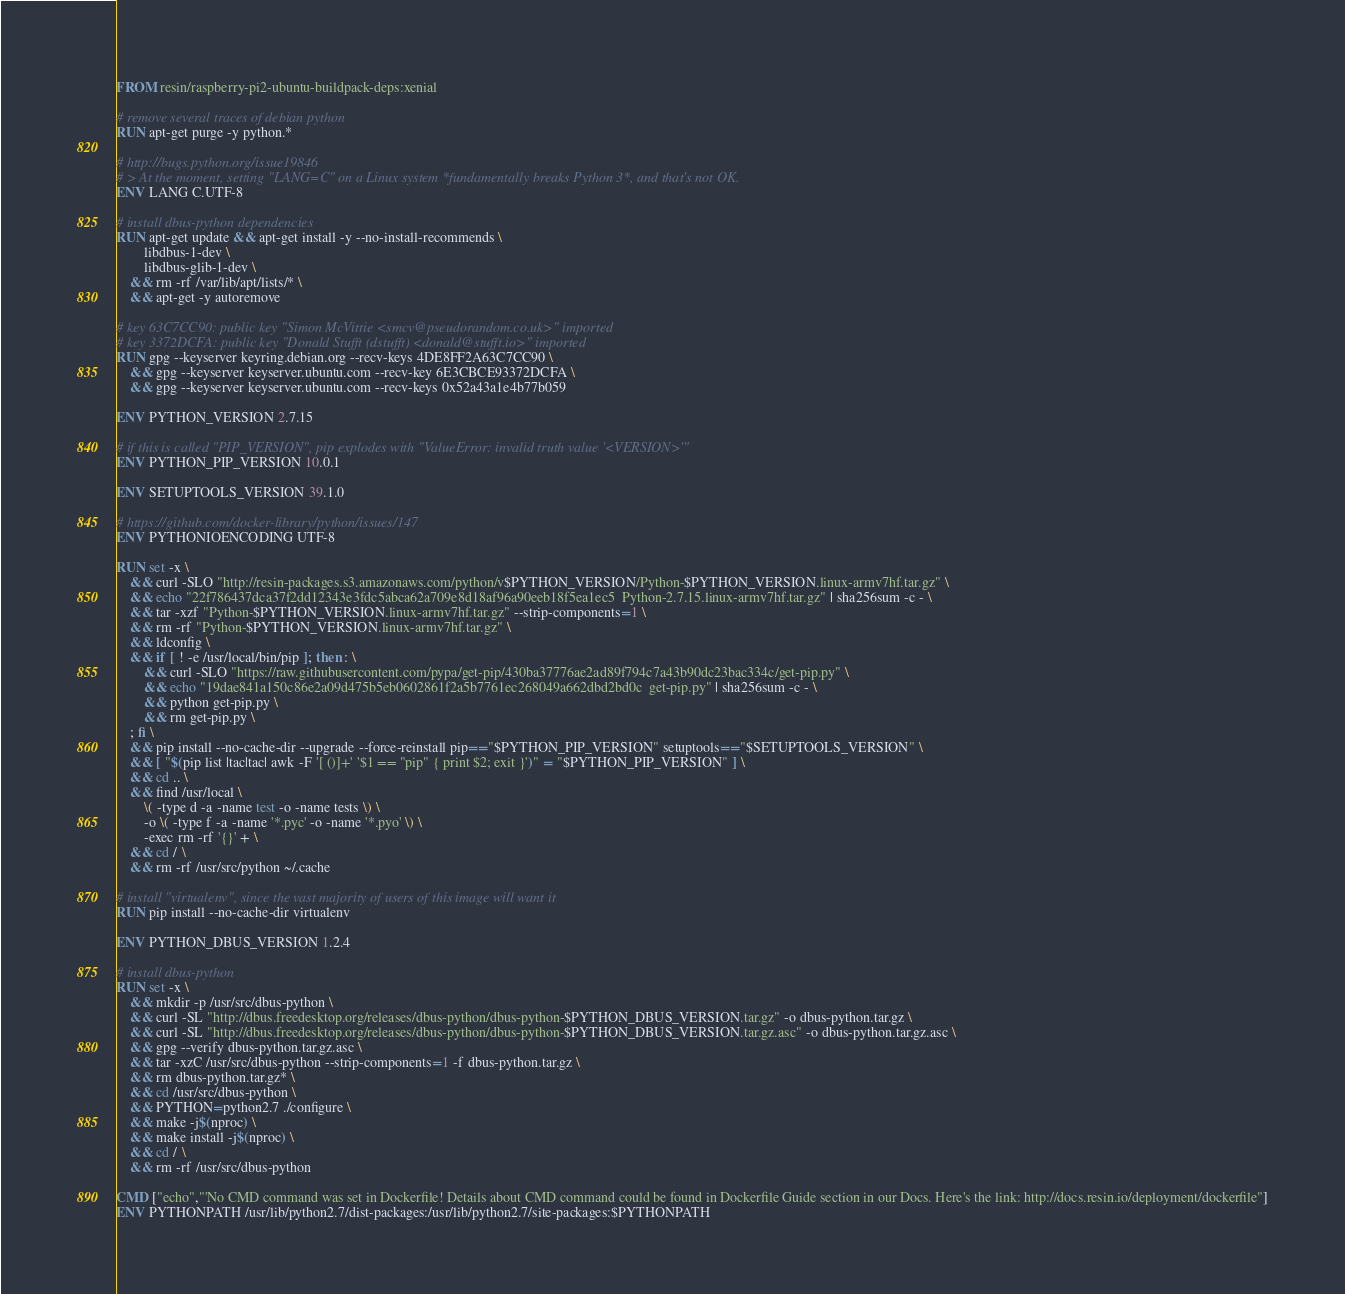<code> <loc_0><loc_0><loc_500><loc_500><_Dockerfile_>FROM resin/raspberry-pi2-ubuntu-buildpack-deps:xenial

# remove several traces of debian python
RUN apt-get purge -y python.*

# http://bugs.python.org/issue19846
# > At the moment, setting "LANG=C" on a Linux system *fundamentally breaks Python 3*, and that's not OK.
ENV LANG C.UTF-8

# install dbus-python dependencies 
RUN apt-get update && apt-get install -y --no-install-recommends \
		libdbus-1-dev \
		libdbus-glib-1-dev \
	&& rm -rf /var/lib/apt/lists/* \
	&& apt-get -y autoremove

# key 63C7CC90: public key "Simon McVittie <smcv@pseudorandom.co.uk>" imported
# key 3372DCFA: public key "Donald Stufft (dstufft) <donald@stufft.io>" imported
RUN gpg --keyserver keyring.debian.org --recv-keys 4DE8FF2A63C7CC90 \
	&& gpg --keyserver keyserver.ubuntu.com --recv-key 6E3CBCE93372DCFA \
	&& gpg --keyserver keyserver.ubuntu.com --recv-keys 0x52a43a1e4b77b059

ENV PYTHON_VERSION 2.7.15

# if this is called "PIP_VERSION", pip explodes with "ValueError: invalid truth value '<VERSION>'"
ENV PYTHON_PIP_VERSION 10.0.1

ENV SETUPTOOLS_VERSION 39.1.0

# https://github.com/docker-library/python/issues/147
ENV PYTHONIOENCODING UTF-8

RUN set -x \
	&& curl -SLO "http://resin-packages.s3.amazonaws.com/python/v$PYTHON_VERSION/Python-$PYTHON_VERSION.linux-armv7hf.tar.gz" \
	&& echo "22f786437dca37f2dd12343e3fdc5abca62a709e8d18af96a90eeb18f5ea1ec5  Python-2.7.15.linux-armv7hf.tar.gz" | sha256sum -c - \
	&& tar -xzf "Python-$PYTHON_VERSION.linux-armv7hf.tar.gz" --strip-components=1 \
	&& rm -rf "Python-$PYTHON_VERSION.linux-armv7hf.tar.gz" \
	&& ldconfig \
	&& if [ ! -e /usr/local/bin/pip ]; then : \
		&& curl -SLO "https://raw.githubusercontent.com/pypa/get-pip/430ba37776ae2ad89f794c7a43b90dc23bac334c/get-pip.py" \
		&& echo "19dae841a150c86e2a09d475b5eb0602861f2a5b7761ec268049a662dbd2bd0c  get-pip.py" | sha256sum -c - \
		&& python get-pip.py \
		&& rm get-pip.py \
	; fi \
	&& pip install --no-cache-dir --upgrade --force-reinstall pip=="$PYTHON_PIP_VERSION" setuptools=="$SETUPTOOLS_VERSION" \
	&& [ "$(pip list |tac|tac| awk -F '[ ()]+' '$1 == "pip" { print $2; exit }')" = "$PYTHON_PIP_VERSION" ] \
	&& cd .. \
	&& find /usr/local \
		\( -type d -a -name test -o -name tests \) \
		-o \( -type f -a -name '*.pyc' -o -name '*.pyo' \) \
		-exec rm -rf '{}' + \
	&& cd / \
	&& rm -rf /usr/src/python ~/.cache

# install "virtualenv", since the vast majority of users of this image will want it
RUN pip install --no-cache-dir virtualenv

ENV PYTHON_DBUS_VERSION 1.2.4

# install dbus-python
RUN set -x \
	&& mkdir -p /usr/src/dbus-python \
	&& curl -SL "http://dbus.freedesktop.org/releases/dbus-python/dbus-python-$PYTHON_DBUS_VERSION.tar.gz" -o dbus-python.tar.gz \
	&& curl -SL "http://dbus.freedesktop.org/releases/dbus-python/dbus-python-$PYTHON_DBUS_VERSION.tar.gz.asc" -o dbus-python.tar.gz.asc \
	&& gpg --verify dbus-python.tar.gz.asc \
	&& tar -xzC /usr/src/dbus-python --strip-components=1 -f dbus-python.tar.gz \
	&& rm dbus-python.tar.gz* \
	&& cd /usr/src/dbus-python \
	&& PYTHON=python2.7 ./configure \
	&& make -j$(nproc) \
	&& make install -j$(nproc) \
	&& cd / \
	&& rm -rf /usr/src/dbus-python

CMD ["echo","'No CMD command was set in Dockerfile! Details about CMD command could be found in Dockerfile Guide section in our Docs. Here's the link: http://docs.resin.io/deployment/dockerfile"]
ENV PYTHONPATH /usr/lib/python2.7/dist-packages:/usr/lib/python2.7/site-packages:$PYTHONPATH
</code> 